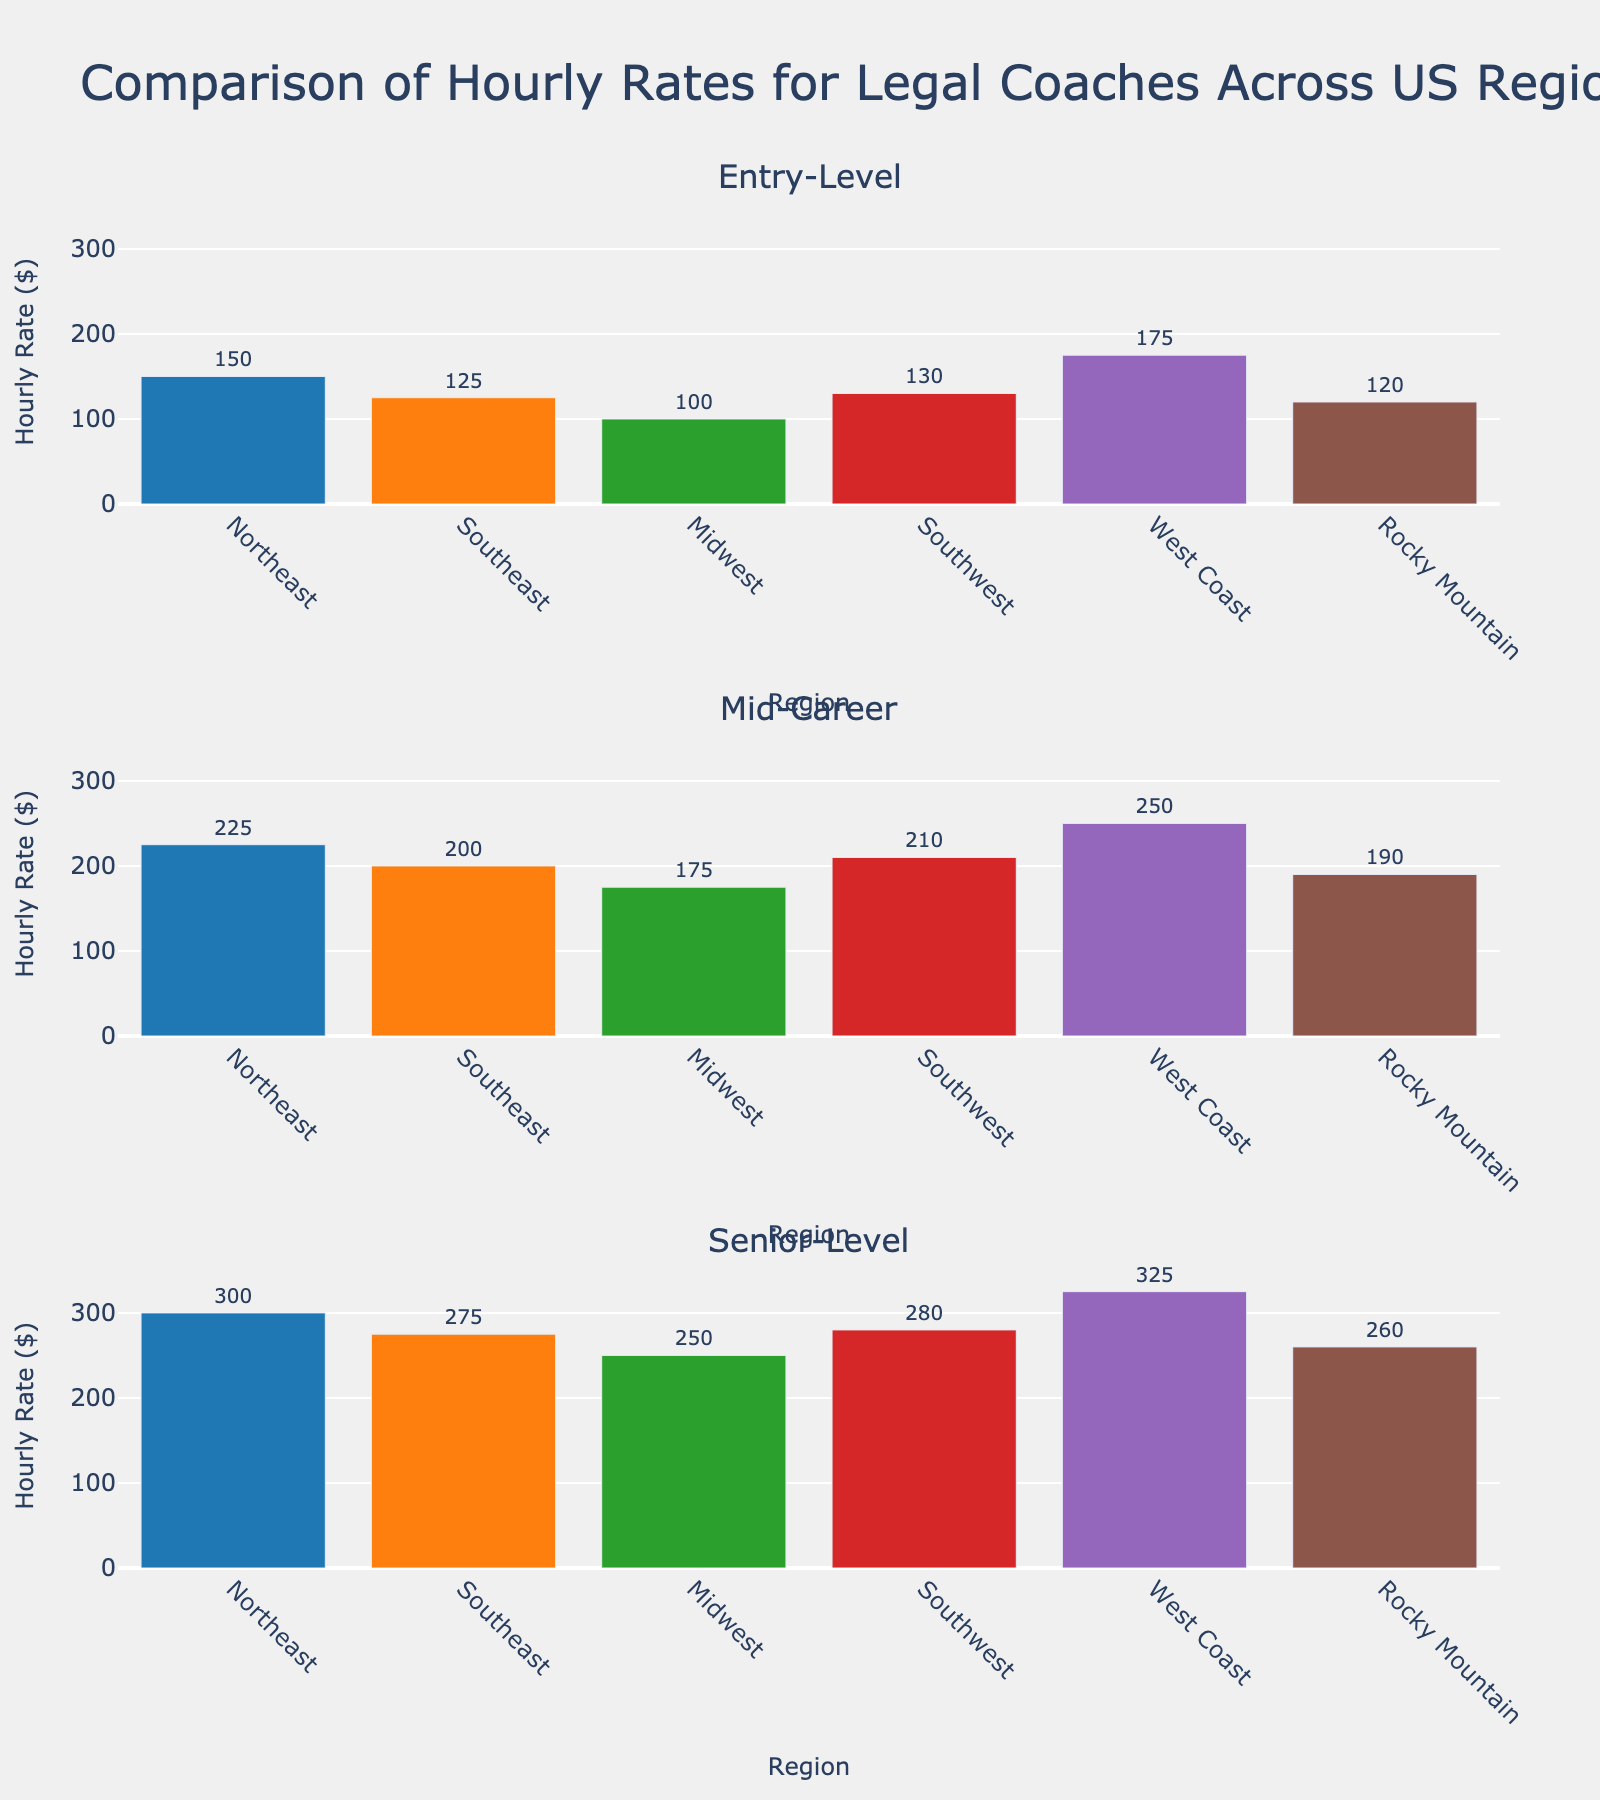what is the title of the figure? The title of a figure is usually placed at the top and gives an overall description of the displayed data. In this case, it reads "Comparison of Hourly Rates for Legal Coaches Across US Regions".
Answer: Comparison of Hourly Rates for Legal Coaches Across US Regions how many regions are displayed in the figure? Each subplot (Entry-Level, Mid-Career, Senior-Level) has bars representing different regions in the US. Counting the bars or regions' names, we see there are 6 regions represented.
Answer: 6 which region has the highest hourly rate for senior-level legal coaches? Look at the third subplot labeled "Senior-Level". Identify the tallest bar, which is for the "West Coast" with an hourly rate of 325.
Answer: West Coast what is the difference in hourly rates between entry-level and senior-level legal coaches in the Midwest? Locate the bars for the Midwest in both the Entry-Level and Senior-Level subplots. The values are 100 for Entry-Level and 250 for Senior-Level. The difference is 250 - 100 = 150.
Answer: 150 which region has the lowest hourly rate for mid-career legal coaches? In the Mid-Career subplot, identify the shortest bar, which is for the "Midwest" with an hourly rate of 175.
Answer: Midwest what is the average hourly rate for entry-level legal coaches across all regions? Add the hourly rates for Entry-Level across all regions: 150 (Northeast) + 125 (Southeast) + 100 (Midwest) + 130 (Southwest) + 175 (West Coast) + 120 (Rocky Mountain) = 800. Divide by the number of regions, 800/6 = 133.33.
Answer: 133.33 how many subplots are there in the figure? By visual inspection, there are three labeled subplots: Entry-Level, Mid-Career, and Senior-Level.
Answer: 3 which region shows the largest increase in hourly rates from entry-level to mid-career? Calculate the increase for each region from Entry-Level to Mid-Career:
- Northeast: 225 - 150 = 75
- Southeast: 200 - 125 = 75
- Midwest: 175 - 100 = 75
- Southwest: 210 - 130 = 80
- West Coast: 250 - 175 = 75
- Rocky Mountain: 190 - 120 = 70
The largest increase is in the Southwest with 80.
Answer: Southwest what is the median hourly rate for senior-level legal coaches across all regions? List the hourly rates for Senior-Level legal coaches across all regions: 300, 275, 250, 280, 325, 260. Order them: 250, 260, 275, 280, 300, 325. The median value (middle value) is the average of the third and fourth values: (275+280)/2 = 277.5.
Answer: 277.5 